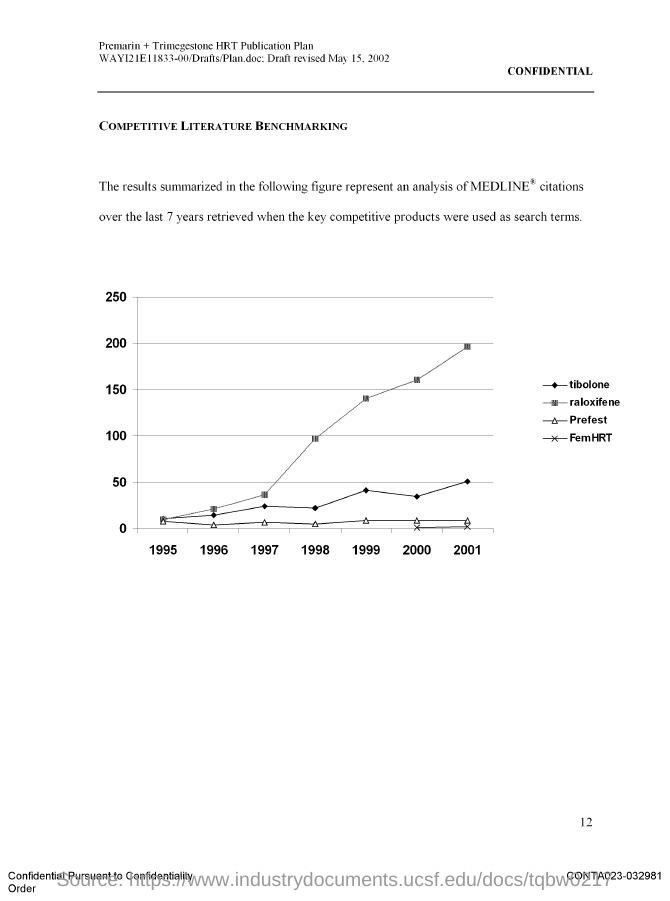When was the draft revised?
Keep it short and to the point. May 15, 2002. What is the title of the graph?
Your answer should be very brief. Competitive Literature Benchmarking. 